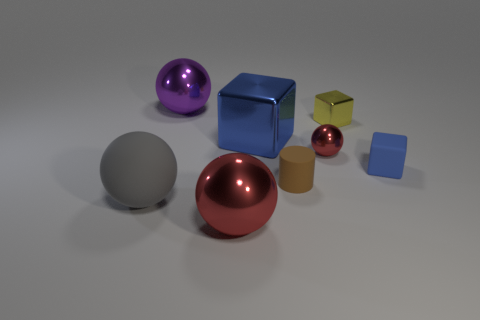Subtract all big purple metallic spheres. How many spheres are left? 3 Subtract 1 balls. How many balls are left? 3 Add 1 yellow metallic cubes. How many objects exist? 9 Subtract all purple spheres. How many spheres are left? 3 Subtract all purple blocks. Subtract all brown balls. How many blocks are left? 3 Subtract all cubes. How many objects are left? 5 Subtract all big cyan things. Subtract all big metallic things. How many objects are left? 5 Add 3 large red things. How many large red things are left? 4 Add 2 small spheres. How many small spheres exist? 3 Subtract 0 brown balls. How many objects are left? 8 